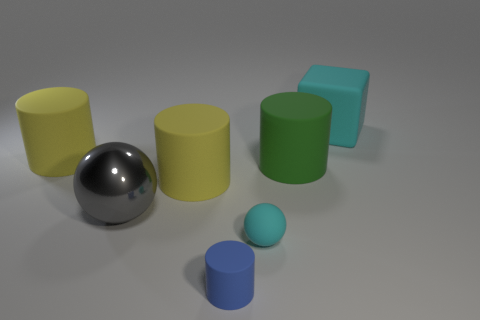What number of other objects are there of the same material as the small blue cylinder?
Ensure brevity in your answer.  5. Is the number of small gray matte cylinders greater than the number of big yellow cylinders?
Offer a very short reply. No. There is a small cyan matte thing that is right of the big gray sphere; is its shape the same as the tiny blue rubber object?
Provide a succinct answer. No. Is the number of cubes less than the number of big red metallic cylinders?
Keep it short and to the point. No. What is the material of the other object that is the same size as the blue thing?
Your answer should be very brief. Rubber. There is a tiny ball; is it the same color as the cube that is to the right of the gray object?
Offer a very short reply. Yes. Are there fewer small cylinders behind the small cyan rubber thing than blue objects?
Your answer should be compact. Yes. What number of large shiny objects are there?
Your response must be concise. 1. The large gray object in front of the cylinder that is on the right side of the small cyan thing is what shape?
Your answer should be very brief. Sphere. What number of large things are to the right of the metal sphere?
Keep it short and to the point. 3. 